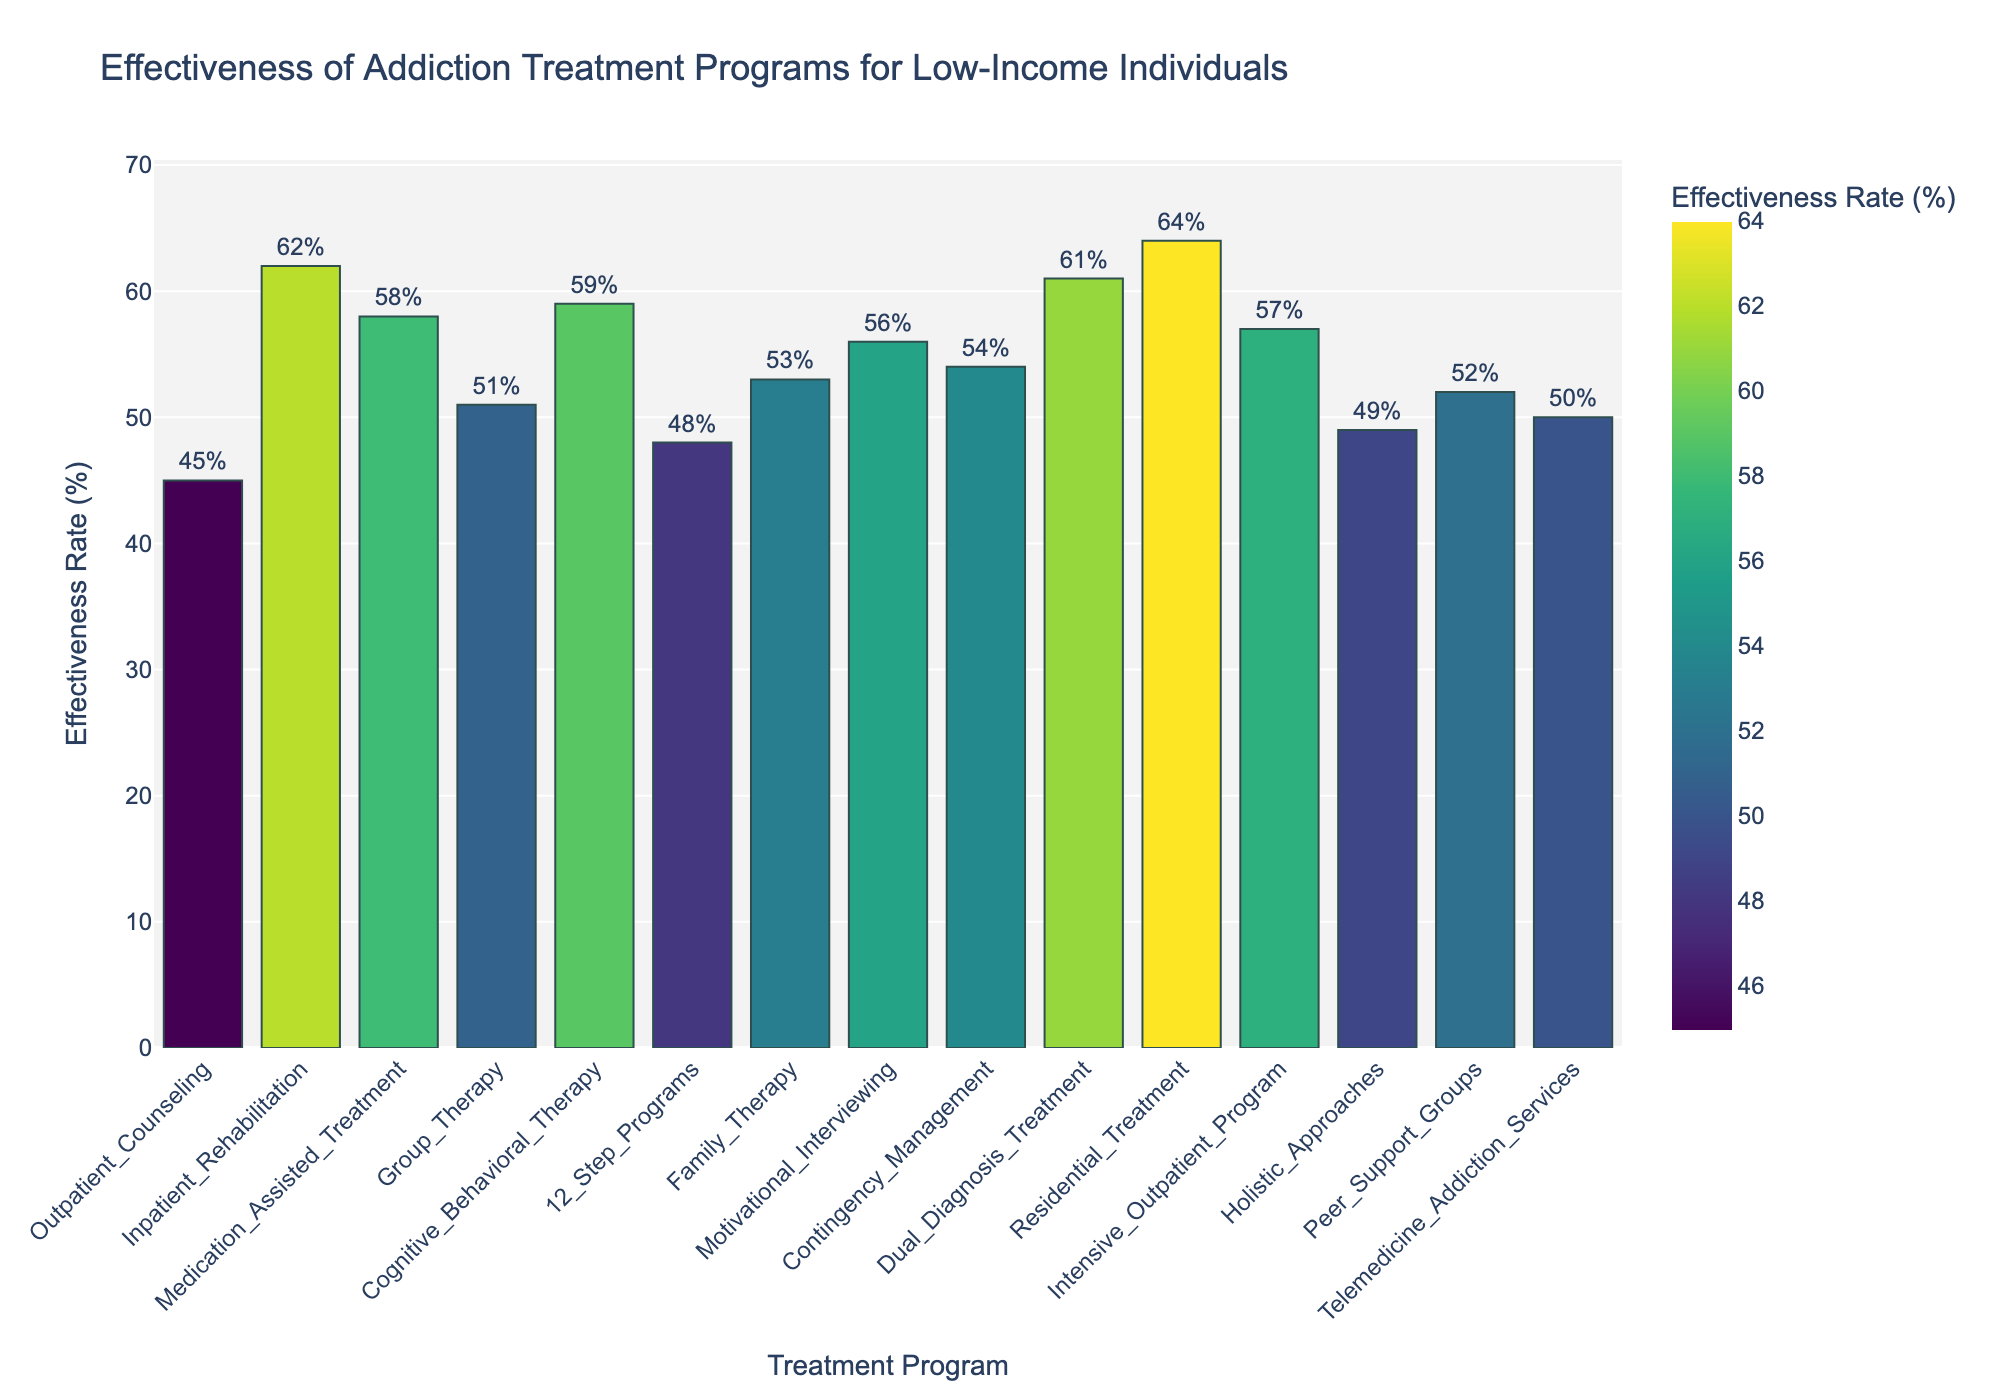What's the most effective treatment program for low-income individuals? The figure shows the effectiveness rate of various treatment programs. The tallest bar represents the most effective program. The bar labeled 'Residential Treatment' is the tallest, with an effectiveness rate of 64%.
Answer: Residential Treatment Which treatment program has a higher effectiveness rate: Inpatient Rehabilitation or Outpatient Counseling? By comparing the heights of the bars for 'Inpatient Rehabilitation' (62%) and 'Outpatient Counseling' (45%), it is clear that 'Inpatient Rehabilitation' has a higher effectiveness rate.
Answer: Inpatient Rehabilitation What's the difference in effectiveness rate between Cognitive Behavioral Therapy and Holistic Approaches? The effectiveness rate for 'Cognitive Behavioral Therapy' is 59%, and for 'Holistic Approaches,' it is 49%. Subtracting these values gives the difference: 59% - 49% = 10%.
Answer: 10% Which treatment programs have an effectiveness rate of over 60%? Observing the bars, the programs with effectiveness rates over 60% are 'Inpatient Rehabilitation,' 'Dual Diagnosis Treatment,' and 'Residential Treatment,' with rates of 62%, 61%, and 64%, respectively.
Answer: Inpatient Rehabilitation, Dual Diagnosis Treatment, Residential Treatment What's the average effectiveness rate of all listed treatment programs? To find the average, sum up all the effectiveness rates and divide by the number of programs. The sum of effectiveness rates is 783%, and there are 15 programs, so the average is 783% / 15 = 52.2%.
Answer: 52.2% How does the effectiveness rate of Medication-Assisted Treatment compare to Peer Support Groups? The effectiveness rate for 'Medication-Assisted Treatment' is 58%, while 'Peer Support Groups' is 52%. 'Medication-Assisted Treatment' has a higher effectiveness rate.
Answer: Medication-Assisted Treatment Which treatment program lies exactly in the middle when effectiveness rates are ordered from highest to lowest? First, order the rates: 64, 62, 61, 59, 58, 57, 56, 54, 53, 52, 51, 50, 49, 48, 45. The 8th value in this sequence is 54%, corresponding to 'Contingency Management.'
Answer: Contingency Management What is the effectiveness rate of the least effective treatment program? The shortest bar represents 'Outpatient Counseling' with an effectiveness rate of 45%, making it the least effective program.
Answer: Outpatient Counseling What is the combined effectiveness rate of Family Therapy and Motivational Interviewing? The effectiveness rates are 51% for 'Family Therapy' and 56% for 'Motivational Interviewing.' Adding these gives: 53% + 56% = 109%.
Answer: 109% 